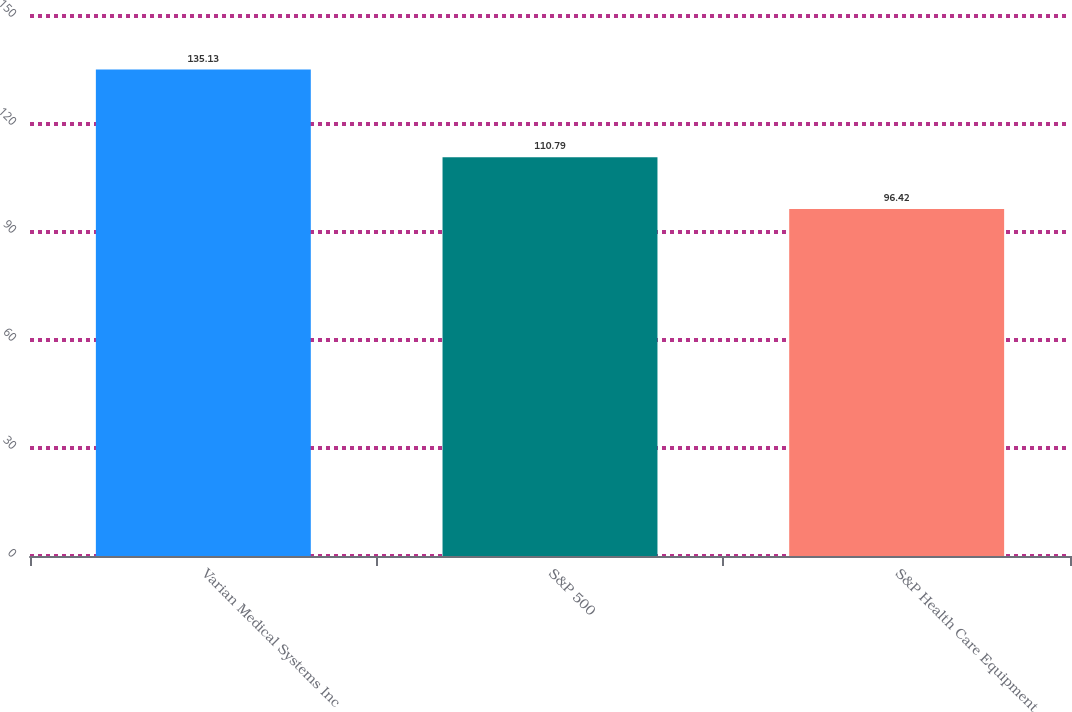<chart> <loc_0><loc_0><loc_500><loc_500><bar_chart><fcel>Varian Medical Systems Inc<fcel>S&P 500<fcel>S&P Health Care Equipment<nl><fcel>135.13<fcel>110.79<fcel>96.42<nl></chart> 